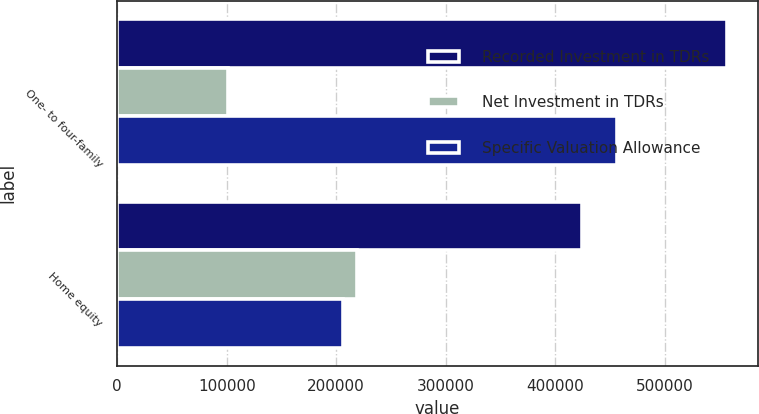Convert chart to OTSL. <chart><loc_0><loc_0><loc_500><loc_500><stacked_bar_chart><ecel><fcel>One- to four-family<fcel>Home equity<nl><fcel>Recorded Investment in TDRs<fcel>557297<fcel>424834<nl><fcel>Net Investment in TDRs<fcel>101188<fcel>218955<nl><fcel>Specific Valuation Allowance<fcel>456109<fcel>205879<nl></chart> 